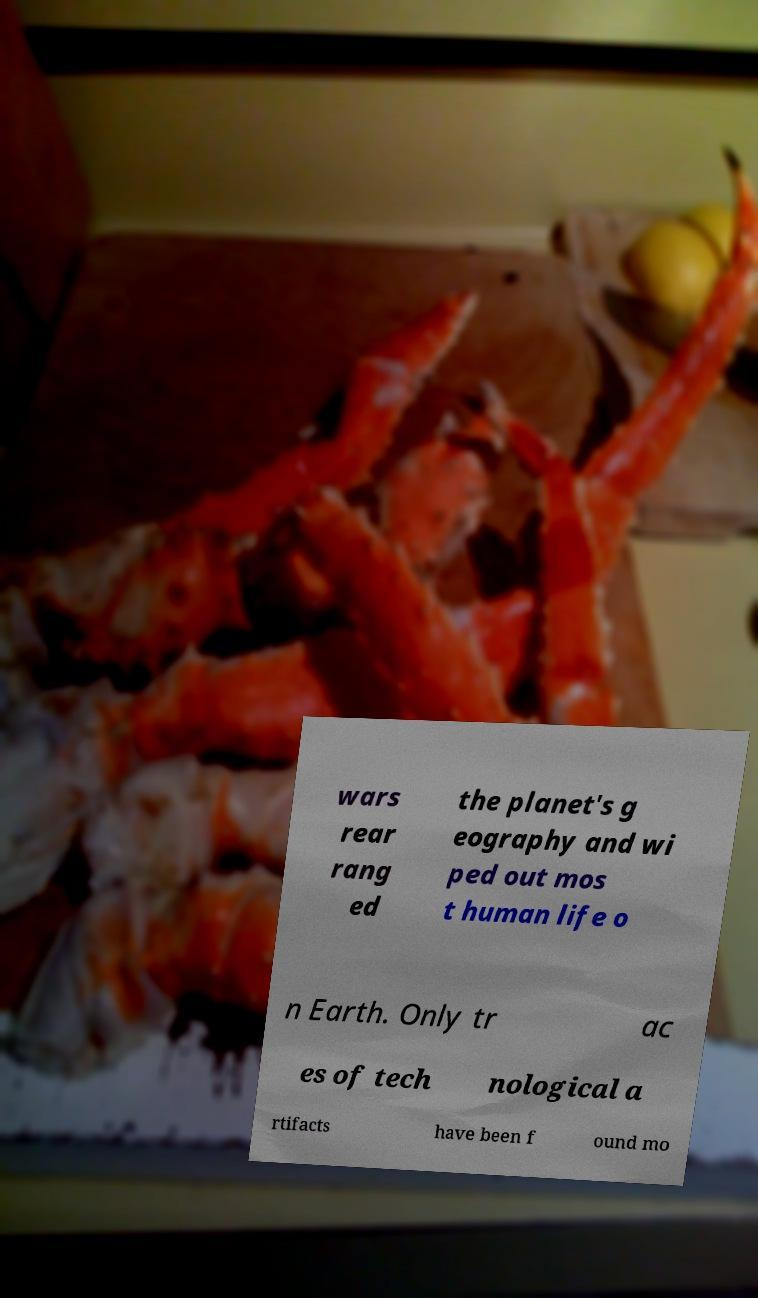Can you accurately transcribe the text from the provided image for me? wars rear rang ed the planet's g eography and wi ped out mos t human life o n Earth. Only tr ac es of tech nological a rtifacts have been f ound mo 